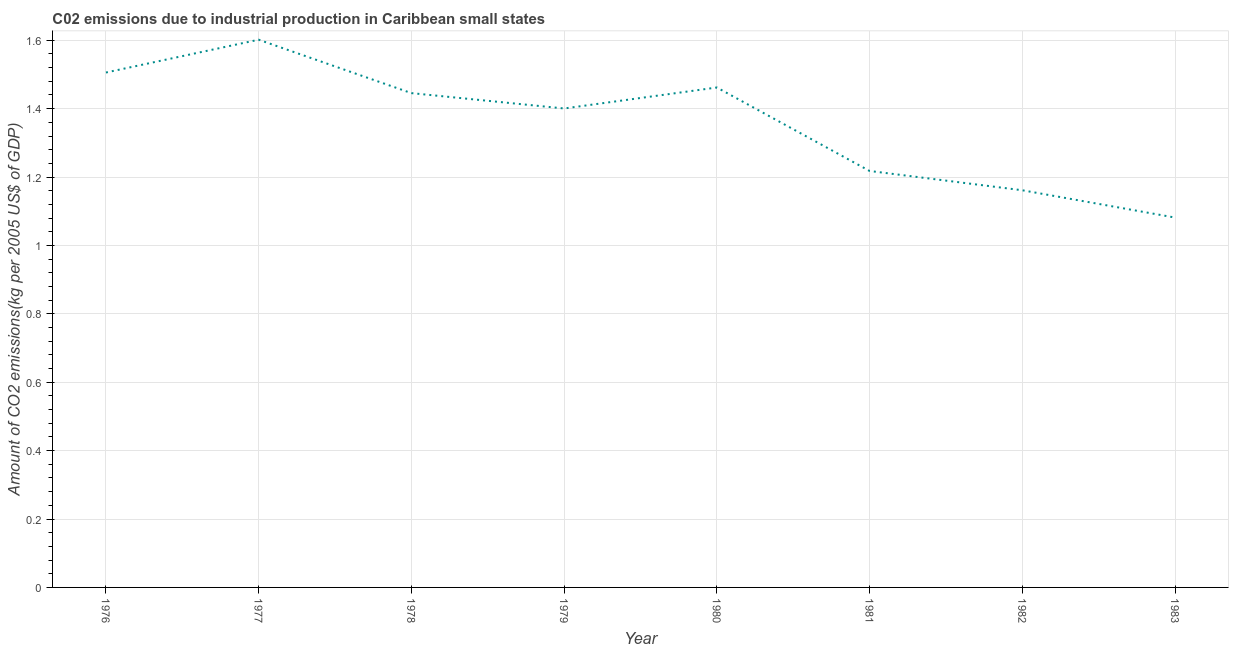What is the amount of co2 emissions in 1983?
Give a very brief answer. 1.08. Across all years, what is the maximum amount of co2 emissions?
Provide a succinct answer. 1.6. Across all years, what is the minimum amount of co2 emissions?
Offer a terse response. 1.08. What is the sum of the amount of co2 emissions?
Your answer should be compact. 10.88. What is the difference between the amount of co2 emissions in 1978 and 1982?
Offer a very short reply. 0.28. What is the average amount of co2 emissions per year?
Your answer should be compact. 1.36. What is the median amount of co2 emissions?
Offer a very short reply. 1.42. What is the ratio of the amount of co2 emissions in 1976 to that in 1977?
Provide a short and direct response. 0.94. Is the amount of co2 emissions in 1976 less than that in 1980?
Provide a short and direct response. No. What is the difference between the highest and the second highest amount of co2 emissions?
Offer a very short reply. 0.1. What is the difference between the highest and the lowest amount of co2 emissions?
Your response must be concise. 0.52. Does the amount of co2 emissions monotonically increase over the years?
Make the answer very short. No. How many years are there in the graph?
Your answer should be very brief. 8. What is the difference between two consecutive major ticks on the Y-axis?
Keep it short and to the point. 0.2. Are the values on the major ticks of Y-axis written in scientific E-notation?
Your answer should be very brief. No. Does the graph contain any zero values?
Make the answer very short. No. Does the graph contain grids?
Keep it short and to the point. Yes. What is the title of the graph?
Ensure brevity in your answer.  C02 emissions due to industrial production in Caribbean small states. What is the label or title of the Y-axis?
Offer a terse response. Amount of CO2 emissions(kg per 2005 US$ of GDP). What is the Amount of CO2 emissions(kg per 2005 US$ of GDP) of 1976?
Your answer should be very brief. 1.51. What is the Amount of CO2 emissions(kg per 2005 US$ of GDP) of 1977?
Keep it short and to the point. 1.6. What is the Amount of CO2 emissions(kg per 2005 US$ of GDP) in 1978?
Make the answer very short. 1.45. What is the Amount of CO2 emissions(kg per 2005 US$ of GDP) in 1979?
Offer a terse response. 1.4. What is the Amount of CO2 emissions(kg per 2005 US$ of GDP) in 1980?
Make the answer very short. 1.46. What is the Amount of CO2 emissions(kg per 2005 US$ of GDP) in 1981?
Offer a terse response. 1.22. What is the Amount of CO2 emissions(kg per 2005 US$ of GDP) in 1982?
Keep it short and to the point. 1.16. What is the Amount of CO2 emissions(kg per 2005 US$ of GDP) in 1983?
Offer a very short reply. 1.08. What is the difference between the Amount of CO2 emissions(kg per 2005 US$ of GDP) in 1976 and 1977?
Provide a short and direct response. -0.1. What is the difference between the Amount of CO2 emissions(kg per 2005 US$ of GDP) in 1976 and 1978?
Your answer should be very brief. 0.06. What is the difference between the Amount of CO2 emissions(kg per 2005 US$ of GDP) in 1976 and 1979?
Make the answer very short. 0.11. What is the difference between the Amount of CO2 emissions(kg per 2005 US$ of GDP) in 1976 and 1980?
Your answer should be compact. 0.04. What is the difference between the Amount of CO2 emissions(kg per 2005 US$ of GDP) in 1976 and 1981?
Ensure brevity in your answer.  0.29. What is the difference between the Amount of CO2 emissions(kg per 2005 US$ of GDP) in 1976 and 1982?
Provide a succinct answer. 0.34. What is the difference between the Amount of CO2 emissions(kg per 2005 US$ of GDP) in 1976 and 1983?
Ensure brevity in your answer.  0.42. What is the difference between the Amount of CO2 emissions(kg per 2005 US$ of GDP) in 1977 and 1978?
Your answer should be compact. 0.16. What is the difference between the Amount of CO2 emissions(kg per 2005 US$ of GDP) in 1977 and 1979?
Offer a very short reply. 0.2. What is the difference between the Amount of CO2 emissions(kg per 2005 US$ of GDP) in 1977 and 1980?
Your answer should be very brief. 0.14. What is the difference between the Amount of CO2 emissions(kg per 2005 US$ of GDP) in 1977 and 1981?
Provide a succinct answer. 0.38. What is the difference between the Amount of CO2 emissions(kg per 2005 US$ of GDP) in 1977 and 1982?
Provide a succinct answer. 0.44. What is the difference between the Amount of CO2 emissions(kg per 2005 US$ of GDP) in 1977 and 1983?
Provide a short and direct response. 0.52. What is the difference between the Amount of CO2 emissions(kg per 2005 US$ of GDP) in 1978 and 1979?
Your response must be concise. 0.04. What is the difference between the Amount of CO2 emissions(kg per 2005 US$ of GDP) in 1978 and 1980?
Offer a terse response. -0.02. What is the difference between the Amount of CO2 emissions(kg per 2005 US$ of GDP) in 1978 and 1981?
Keep it short and to the point. 0.23. What is the difference between the Amount of CO2 emissions(kg per 2005 US$ of GDP) in 1978 and 1982?
Make the answer very short. 0.28. What is the difference between the Amount of CO2 emissions(kg per 2005 US$ of GDP) in 1978 and 1983?
Your response must be concise. 0.36. What is the difference between the Amount of CO2 emissions(kg per 2005 US$ of GDP) in 1979 and 1980?
Make the answer very short. -0.06. What is the difference between the Amount of CO2 emissions(kg per 2005 US$ of GDP) in 1979 and 1981?
Offer a very short reply. 0.18. What is the difference between the Amount of CO2 emissions(kg per 2005 US$ of GDP) in 1979 and 1982?
Give a very brief answer. 0.24. What is the difference between the Amount of CO2 emissions(kg per 2005 US$ of GDP) in 1979 and 1983?
Provide a short and direct response. 0.32. What is the difference between the Amount of CO2 emissions(kg per 2005 US$ of GDP) in 1980 and 1981?
Offer a terse response. 0.24. What is the difference between the Amount of CO2 emissions(kg per 2005 US$ of GDP) in 1980 and 1982?
Ensure brevity in your answer.  0.3. What is the difference between the Amount of CO2 emissions(kg per 2005 US$ of GDP) in 1980 and 1983?
Provide a succinct answer. 0.38. What is the difference between the Amount of CO2 emissions(kg per 2005 US$ of GDP) in 1981 and 1982?
Keep it short and to the point. 0.06. What is the difference between the Amount of CO2 emissions(kg per 2005 US$ of GDP) in 1981 and 1983?
Provide a succinct answer. 0.14. What is the difference between the Amount of CO2 emissions(kg per 2005 US$ of GDP) in 1982 and 1983?
Make the answer very short. 0.08. What is the ratio of the Amount of CO2 emissions(kg per 2005 US$ of GDP) in 1976 to that in 1977?
Your answer should be compact. 0.94. What is the ratio of the Amount of CO2 emissions(kg per 2005 US$ of GDP) in 1976 to that in 1978?
Your response must be concise. 1.04. What is the ratio of the Amount of CO2 emissions(kg per 2005 US$ of GDP) in 1976 to that in 1979?
Make the answer very short. 1.07. What is the ratio of the Amount of CO2 emissions(kg per 2005 US$ of GDP) in 1976 to that in 1980?
Provide a succinct answer. 1.03. What is the ratio of the Amount of CO2 emissions(kg per 2005 US$ of GDP) in 1976 to that in 1981?
Give a very brief answer. 1.24. What is the ratio of the Amount of CO2 emissions(kg per 2005 US$ of GDP) in 1976 to that in 1982?
Make the answer very short. 1.3. What is the ratio of the Amount of CO2 emissions(kg per 2005 US$ of GDP) in 1976 to that in 1983?
Make the answer very short. 1.39. What is the ratio of the Amount of CO2 emissions(kg per 2005 US$ of GDP) in 1977 to that in 1978?
Your response must be concise. 1.11. What is the ratio of the Amount of CO2 emissions(kg per 2005 US$ of GDP) in 1977 to that in 1979?
Provide a succinct answer. 1.14. What is the ratio of the Amount of CO2 emissions(kg per 2005 US$ of GDP) in 1977 to that in 1980?
Your response must be concise. 1.1. What is the ratio of the Amount of CO2 emissions(kg per 2005 US$ of GDP) in 1977 to that in 1981?
Offer a very short reply. 1.31. What is the ratio of the Amount of CO2 emissions(kg per 2005 US$ of GDP) in 1977 to that in 1982?
Make the answer very short. 1.38. What is the ratio of the Amount of CO2 emissions(kg per 2005 US$ of GDP) in 1977 to that in 1983?
Your answer should be very brief. 1.48. What is the ratio of the Amount of CO2 emissions(kg per 2005 US$ of GDP) in 1978 to that in 1979?
Give a very brief answer. 1.03. What is the ratio of the Amount of CO2 emissions(kg per 2005 US$ of GDP) in 1978 to that in 1981?
Your response must be concise. 1.19. What is the ratio of the Amount of CO2 emissions(kg per 2005 US$ of GDP) in 1978 to that in 1982?
Keep it short and to the point. 1.25. What is the ratio of the Amount of CO2 emissions(kg per 2005 US$ of GDP) in 1978 to that in 1983?
Offer a terse response. 1.34. What is the ratio of the Amount of CO2 emissions(kg per 2005 US$ of GDP) in 1979 to that in 1980?
Your answer should be compact. 0.96. What is the ratio of the Amount of CO2 emissions(kg per 2005 US$ of GDP) in 1979 to that in 1981?
Provide a short and direct response. 1.15. What is the ratio of the Amount of CO2 emissions(kg per 2005 US$ of GDP) in 1979 to that in 1982?
Ensure brevity in your answer.  1.21. What is the ratio of the Amount of CO2 emissions(kg per 2005 US$ of GDP) in 1979 to that in 1983?
Provide a succinct answer. 1.29. What is the ratio of the Amount of CO2 emissions(kg per 2005 US$ of GDP) in 1980 to that in 1982?
Give a very brief answer. 1.26. What is the ratio of the Amount of CO2 emissions(kg per 2005 US$ of GDP) in 1980 to that in 1983?
Provide a succinct answer. 1.35. What is the ratio of the Amount of CO2 emissions(kg per 2005 US$ of GDP) in 1981 to that in 1982?
Provide a succinct answer. 1.05. What is the ratio of the Amount of CO2 emissions(kg per 2005 US$ of GDP) in 1981 to that in 1983?
Provide a short and direct response. 1.13. What is the ratio of the Amount of CO2 emissions(kg per 2005 US$ of GDP) in 1982 to that in 1983?
Your answer should be very brief. 1.07. 